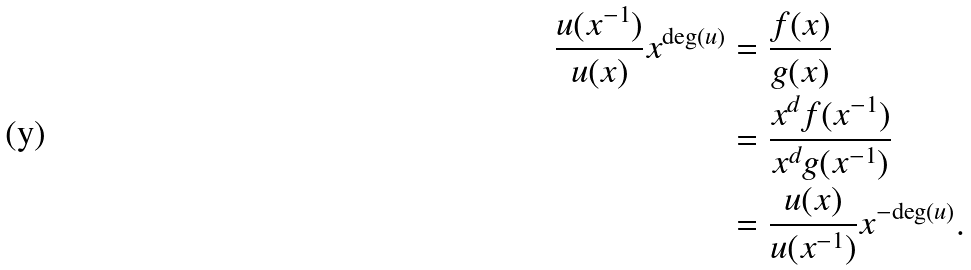<formula> <loc_0><loc_0><loc_500><loc_500>\frac { u ( x ^ { - 1 } ) } { u ( x ) } x ^ { \text {deg} ( u ) } & = \frac { f ( x ) } { g ( x ) } \\ & = \frac { x ^ { d } f ( x ^ { - 1 } ) } { x ^ { d } g ( x ^ { - 1 } ) } \\ & = \frac { u ( x ) } { u ( x ^ { - 1 } ) } x ^ { - \text {deg} ( u ) } . \\</formula> 